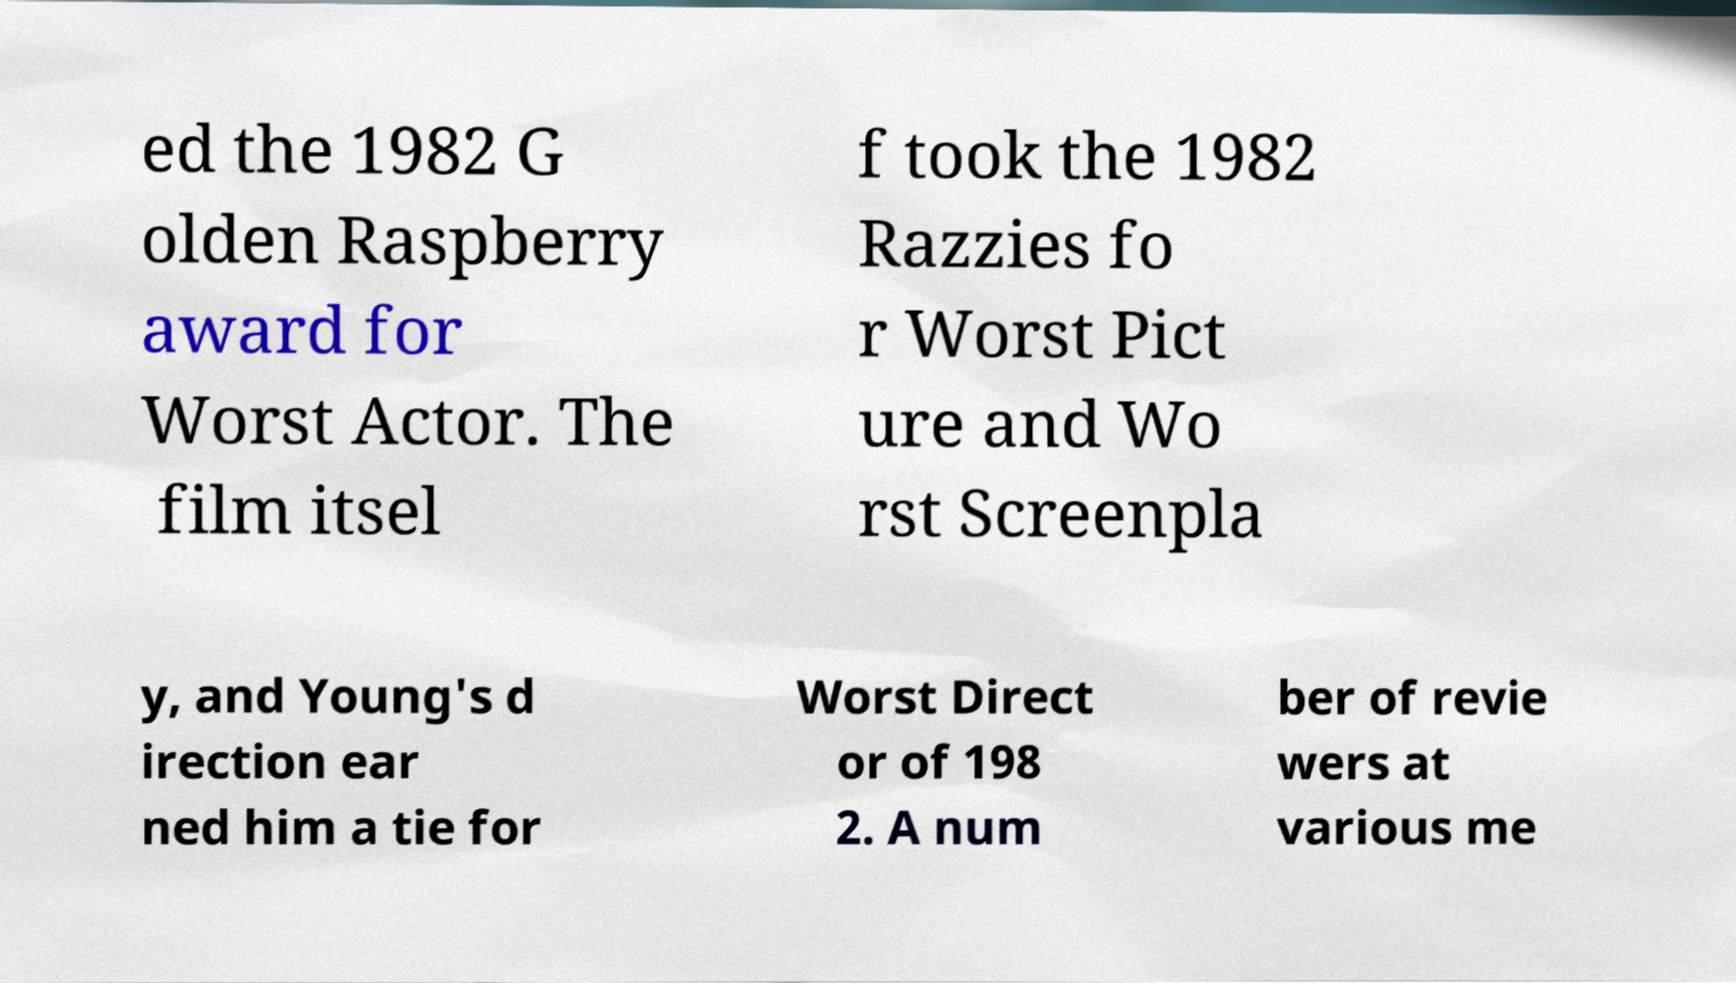For documentation purposes, I need the text within this image transcribed. Could you provide that? ed the 1982 G olden Raspberry award for Worst Actor. The film itsel f took the 1982 Razzies fo r Worst Pict ure and Wo rst Screenpla y, and Young's d irection ear ned him a tie for Worst Direct or of 198 2. A num ber of revie wers at various me 